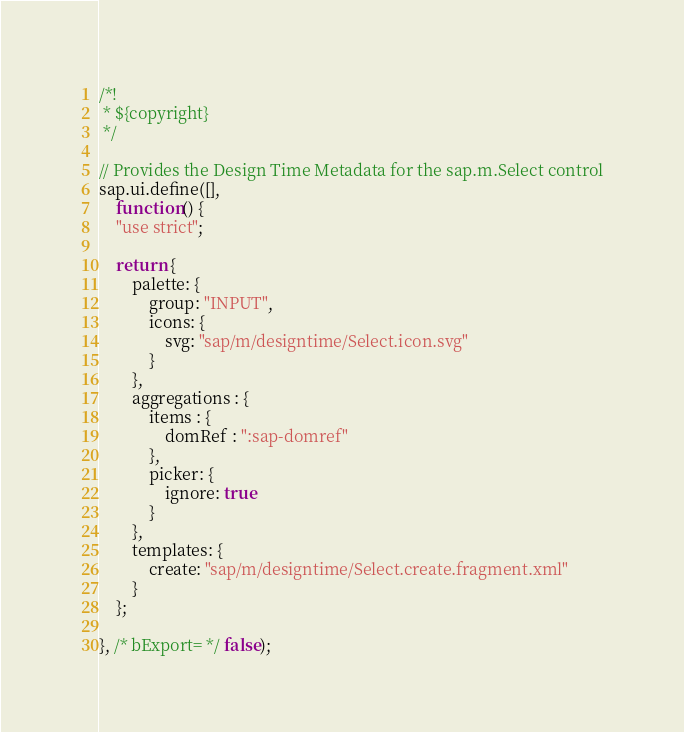Convert code to text. <code><loc_0><loc_0><loc_500><loc_500><_JavaScript_>/*!
 * ${copyright}
 */

// Provides the Design Time Metadata for the sap.m.Select control
sap.ui.define([],
	function() {
	"use strict";

	return {
		palette: {
			group: "INPUT",
			icons: {
				svg: "sap/m/designtime/Select.icon.svg"
			}
		},
		aggregations : {
			items : {
				domRef : ":sap-domref"
			},
			picker: {
				ignore: true
			}
		},
		templates: {
			create: "sap/m/designtime/Select.create.fragment.xml"
		}
	};

}, /* bExport= */ false);
</code> 